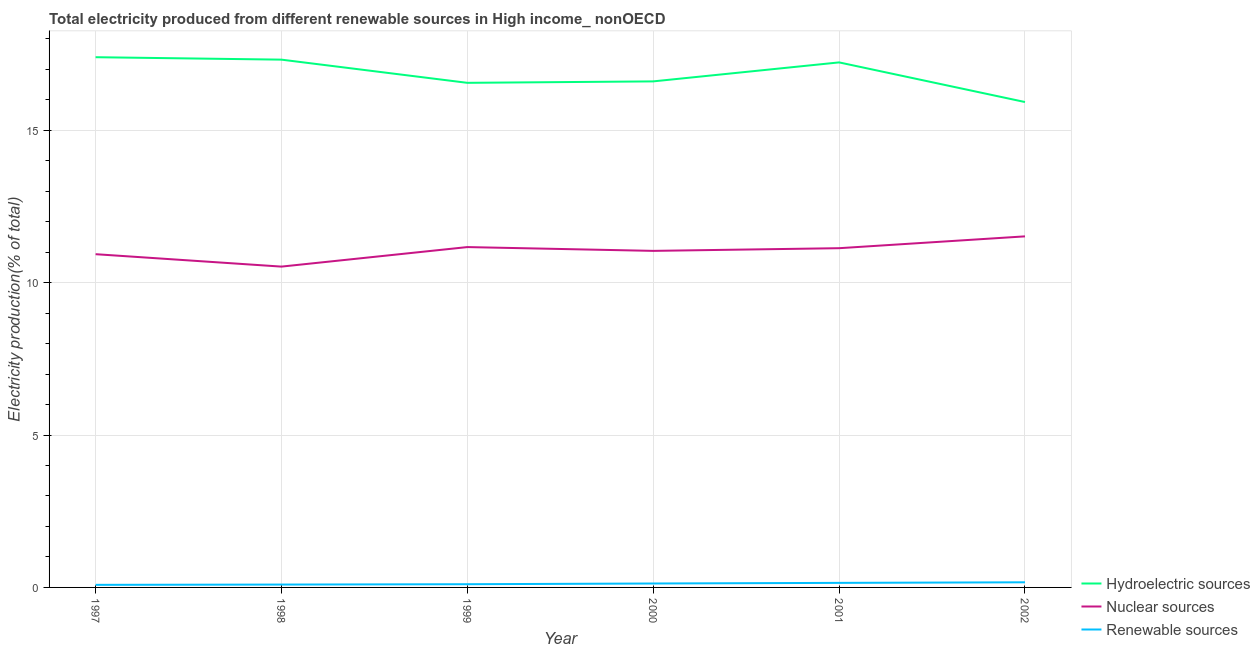How many different coloured lines are there?
Give a very brief answer. 3. Does the line corresponding to percentage of electricity produced by nuclear sources intersect with the line corresponding to percentage of electricity produced by renewable sources?
Ensure brevity in your answer.  No. Is the number of lines equal to the number of legend labels?
Make the answer very short. Yes. What is the percentage of electricity produced by nuclear sources in 1997?
Give a very brief answer. 10.93. Across all years, what is the maximum percentage of electricity produced by nuclear sources?
Offer a terse response. 11.52. Across all years, what is the minimum percentage of electricity produced by hydroelectric sources?
Ensure brevity in your answer.  15.92. In which year was the percentage of electricity produced by nuclear sources minimum?
Provide a short and direct response. 1998. What is the total percentage of electricity produced by hydroelectric sources in the graph?
Ensure brevity in your answer.  101.01. What is the difference between the percentage of electricity produced by renewable sources in 1997 and that in 1999?
Your answer should be very brief. -0.02. What is the difference between the percentage of electricity produced by renewable sources in 1997 and the percentage of electricity produced by nuclear sources in 2002?
Your answer should be compact. -11.43. What is the average percentage of electricity produced by hydroelectric sources per year?
Offer a very short reply. 16.83. In the year 2000, what is the difference between the percentage of electricity produced by nuclear sources and percentage of electricity produced by hydroelectric sources?
Your answer should be compact. -5.56. In how many years, is the percentage of electricity produced by nuclear sources greater than 12 %?
Keep it short and to the point. 0. What is the ratio of the percentage of electricity produced by nuclear sources in 1997 to that in 1999?
Provide a short and direct response. 0.98. Is the percentage of electricity produced by nuclear sources in 2000 less than that in 2001?
Provide a short and direct response. Yes. Is the difference between the percentage of electricity produced by renewable sources in 1997 and 2000 greater than the difference between the percentage of electricity produced by hydroelectric sources in 1997 and 2000?
Provide a succinct answer. No. What is the difference between the highest and the second highest percentage of electricity produced by renewable sources?
Ensure brevity in your answer.  0.02. What is the difference between the highest and the lowest percentage of electricity produced by renewable sources?
Make the answer very short. 0.08. In how many years, is the percentage of electricity produced by renewable sources greater than the average percentage of electricity produced by renewable sources taken over all years?
Your answer should be compact. 3. Is the percentage of electricity produced by renewable sources strictly less than the percentage of electricity produced by hydroelectric sources over the years?
Offer a terse response. Yes. How many lines are there?
Ensure brevity in your answer.  3. How many years are there in the graph?
Offer a terse response. 6. Are the values on the major ticks of Y-axis written in scientific E-notation?
Keep it short and to the point. No. Does the graph contain any zero values?
Your answer should be compact. No. How are the legend labels stacked?
Offer a terse response. Vertical. What is the title of the graph?
Offer a terse response. Total electricity produced from different renewable sources in High income_ nonOECD. Does "Services" appear as one of the legend labels in the graph?
Provide a succinct answer. No. What is the label or title of the Y-axis?
Ensure brevity in your answer.  Electricity production(% of total). What is the Electricity production(% of total) of Hydroelectric sources in 1997?
Keep it short and to the point. 17.39. What is the Electricity production(% of total) in Nuclear sources in 1997?
Provide a short and direct response. 10.93. What is the Electricity production(% of total) of Renewable sources in 1997?
Offer a terse response. 0.08. What is the Electricity production(% of total) of Hydroelectric sources in 1998?
Provide a succinct answer. 17.31. What is the Electricity production(% of total) of Nuclear sources in 1998?
Make the answer very short. 10.52. What is the Electricity production(% of total) of Renewable sources in 1998?
Offer a very short reply. 0.09. What is the Electricity production(% of total) of Hydroelectric sources in 1999?
Make the answer very short. 16.55. What is the Electricity production(% of total) in Nuclear sources in 1999?
Give a very brief answer. 11.17. What is the Electricity production(% of total) in Renewable sources in 1999?
Give a very brief answer. 0.11. What is the Electricity production(% of total) in Hydroelectric sources in 2000?
Provide a succinct answer. 16.6. What is the Electricity production(% of total) in Nuclear sources in 2000?
Ensure brevity in your answer.  11.04. What is the Electricity production(% of total) of Renewable sources in 2000?
Ensure brevity in your answer.  0.13. What is the Electricity production(% of total) of Hydroelectric sources in 2001?
Keep it short and to the point. 17.22. What is the Electricity production(% of total) of Nuclear sources in 2001?
Keep it short and to the point. 11.13. What is the Electricity production(% of total) in Renewable sources in 2001?
Provide a short and direct response. 0.15. What is the Electricity production(% of total) of Hydroelectric sources in 2002?
Give a very brief answer. 15.92. What is the Electricity production(% of total) of Nuclear sources in 2002?
Give a very brief answer. 11.52. What is the Electricity production(% of total) of Renewable sources in 2002?
Make the answer very short. 0.17. Across all years, what is the maximum Electricity production(% of total) in Hydroelectric sources?
Ensure brevity in your answer.  17.39. Across all years, what is the maximum Electricity production(% of total) in Nuclear sources?
Keep it short and to the point. 11.52. Across all years, what is the maximum Electricity production(% of total) of Renewable sources?
Your answer should be compact. 0.17. Across all years, what is the minimum Electricity production(% of total) in Hydroelectric sources?
Ensure brevity in your answer.  15.92. Across all years, what is the minimum Electricity production(% of total) of Nuclear sources?
Offer a terse response. 10.52. Across all years, what is the minimum Electricity production(% of total) of Renewable sources?
Make the answer very short. 0.08. What is the total Electricity production(% of total) in Hydroelectric sources in the graph?
Make the answer very short. 101.01. What is the total Electricity production(% of total) in Nuclear sources in the graph?
Your response must be concise. 66.31. What is the total Electricity production(% of total) in Renewable sources in the graph?
Your answer should be very brief. 0.73. What is the difference between the Electricity production(% of total) of Hydroelectric sources in 1997 and that in 1998?
Your response must be concise. 0.08. What is the difference between the Electricity production(% of total) in Nuclear sources in 1997 and that in 1998?
Keep it short and to the point. 0.41. What is the difference between the Electricity production(% of total) in Renewable sources in 1997 and that in 1998?
Keep it short and to the point. -0.01. What is the difference between the Electricity production(% of total) of Hydroelectric sources in 1997 and that in 1999?
Offer a terse response. 0.84. What is the difference between the Electricity production(% of total) in Nuclear sources in 1997 and that in 1999?
Your answer should be compact. -0.23. What is the difference between the Electricity production(% of total) of Renewable sources in 1997 and that in 1999?
Give a very brief answer. -0.02. What is the difference between the Electricity production(% of total) in Hydroelectric sources in 1997 and that in 2000?
Your answer should be very brief. 0.79. What is the difference between the Electricity production(% of total) of Nuclear sources in 1997 and that in 2000?
Provide a succinct answer. -0.11. What is the difference between the Electricity production(% of total) of Renewable sources in 1997 and that in 2000?
Give a very brief answer. -0.04. What is the difference between the Electricity production(% of total) of Hydroelectric sources in 1997 and that in 2001?
Ensure brevity in your answer.  0.17. What is the difference between the Electricity production(% of total) in Nuclear sources in 1997 and that in 2001?
Ensure brevity in your answer.  -0.2. What is the difference between the Electricity production(% of total) of Renewable sources in 1997 and that in 2001?
Make the answer very short. -0.06. What is the difference between the Electricity production(% of total) in Hydroelectric sources in 1997 and that in 2002?
Your answer should be very brief. 1.47. What is the difference between the Electricity production(% of total) in Nuclear sources in 1997 and that in 2002?
Offer a terse response. -0.58. What is the difference between the Electricity production(% of total) in Renewable sources in 1997 and that in 2002?
Your answer should be compact. -0.08. What is the difference between the Electricity production(% of total) of Hydroelectric sources in 1998 and that in 1999?
Your response must be concise. 0.76. What is the difference between the Electricity production(% of total) in Nuclear sources in 1998 and that in 1999?
Offer a very short reply. -0.64. What is the difference between the Electricity production(% of total) in Renewable sources in 1998 and that in 1999?
Offer a terse response. -0.01. What is the difference between the Electricity production(% of total) of Hydroelectric sources in 1998 and that in 2000?
Your answer should be very brief. 0.71. What is the difference between the Electricity production(% of total) of Nuclear sources in 1998 and that in 2000?
Make the answer very short. -0.52. What is the difference between the Electricity production(% of total) in Renewable sources in 1998 and that in 2000?
Offer a terse response. -0.03. What is the difference between the Electricity production(% of total) of Hydroelectric sources in 1998 and that in 2001?
Provide a short and direct response. 0.09. What is the difference between the Electricity production(% of total) of Nuclear sources in 1998 and that in 2001?
Offer a very short reply. -0.6. What is the difference between the Electricity production(% of total) in Renewable sources in 1998 and that in 2001?
Provide a short and direct response. -0.06. What is the difference between the Electricity production(% of total) of Hydroelectric sources in 1998 and that in 2002?
Keep it short and to the point. 1.39. What is the difference between the Electricity production(% of total) of Nuclear sources in 1998 and that in 2002?
Offer a very short reply. -0.99. What is the difference between the Electricity production(% of total) of Renewable sources in 1998 and that in 2002?
Give a very brief answer. -0.07. What is the difference between the Electricity production(% of total) in Hydroelectric sources in 1999 and that in 2000?
Keep it short and to the point. -0.05. What is the difference between the Electricity production(% of total) in Nuclear sources in 1999 and that in 2000?
Keep it short and to the point. 0.12. What is the difference between the Electricity production(% of total) in Renewable sources in 1999 and that in 2000?
Your response must be concise. -0.02. What is the difference between the Electricity production(% of total) in Hydroelectric sources in 1999 and that in 2001?
Your answer should be very brief. -0.67. What is the difference between the Electricity production(% of total) of Nuclear sources in 1999 and that in 2001?
Provide a succinct answer. 0.04. What is the difference between the Electricity production(% of total) of Renewable sources in 1999 and that in 2001?
Your answer should be very brief. -0.04. What is the difference between the Electricity production(% of total) of Hydroelectric sources in 1999 and that in 2002?
Offer a very short reply. 0.63. What is the difference between the Electricity production(% of total) in Nuclear sources in 1999 and that in 2002?
Keep it short and to the point. -0.35. What is the difference between the Electricity production(% of total) of Renewable sources in 1999 and that in 2002?
Offer a very short reply. -0.06. What is the difference between the Electricity production(% of total) in Hydroelectric sources in 2000 and that in 2001?
Your response must be concise. -0.62. What is the difference between the Electricity production(% of total) of Nuclear sources in 2000 and that in 2001?
Your response must be concise. -0.09. What is the difference between the Electricity production(% of total) of Renewable sources in 2000 and that in 2001?
Offer a very short reply. -0.02. What is the difference between the Electricity production(% of total) of Hydroelectric sources in 2000 and that in 2002?
Provide a short and direct response. 0.68. What is the difference between the Electricity production(% of total) of Nuclear sources in 2000 and that in 2002?
Provide a succinct answer. -0.48. What is the difference between the Electricity production(% of total) of Renewable sources in 2000 and that in 2002?
Keep it short and to the point. -0.04. What is the difference between the Electricity production(% of total) in Nuclear sources in 2001 and that in 2002?
Provide a short and direct response. -0.39. What is the difference between the Electricity production(% of total) in Renewable sources in 2001 and that in 2002?
Your answer should be very brief. -0.02. What is the difference between the Electricity production(% of total) in Hydroelectric sources in 1997 and the Electricity production(% of total) in Nuclear sources in 1998?
Provide a short and direct response. 6.87. What is the difference between the Electricity production(% of total) in Hydroelectric sources in 1997 and the Electricity production(% of total) in Renewable sources in 1998?
Your answer should be very brief. 17.3. What is the difference between the Electricity production(% of total) of Nuclear sources in 1997 and the Electricity production(% of total) of Renewable sources in 1998?
Provide a short and direct response. 10.84. What is the difference between the Electricity production(% of total) of Hydroelectric sources in 1997 and the Electricity production(% of total) of Nuclear sources in 1999?
Ensure brevity in your answer.  6.23. What is the difference between the Electricity production(% of total) in Hydroelectric sources in 1997 and the Electricity production(% of total) in Renewable sources in 1999?
Provide a succinct answer. 17.29. What is the difference between the Electricity production(% of total) in Nuclear sources in 1997 and the Electricity production(% of total) in Renewable sources in 1999?
Keep it short and to the point. 10.83. What is the difference between the Electricity production(% of total) of Hydroelectric sources in 1997 and the Electricity production(% of total) of Nuclear sources in 2000?
Your answer should be very brief. 6.35. What is the difference between the Electricity production(% of total) of Hydroelectric sources in 1997 and the Electricity production(% of total) of Renewable sources in 2000?
Offer a terse response. 17.27. What is the difference between the Electricity production(% of total) in Nuclear sources in 1997 and the Electricity production(% of total) in Renewable sources in 2000?
Provide a short and direct response. 10.8. What is the difference between the Electricity production(% of total) of Hydroelectric sources in 1997 and the Electricity production(% of total) of Nuclear sources in 2001?
Your answer should be compact. 6.27. What is the difference between the Electricity production(% of total) of Hydroelectric sources in 1997 and the Electricity production(% of total) of Renewable sources in 2001?
Offer a terse response. 17.24. What is the difference between the Electricity production(% of total) in Nuclear sources in 1997 and the Electricity production(% of total) in Renewable sources in 2001?
Make the answer very short. 10.78. What is the difference between the Electricity production(% of total) of Hydroelectric sources in 1997 and the Electricity production(% of total) of Nuclear sources in 2002?
Your answer should be very brief. 5.88. What is the difference between the Electricity production(% of total) of Hydroelectric sources in 1997 and the Electricity production(% of total) of Renewable sources in 2002?
Keep it short and to the point. 17.23. What is the difference between the Electricity production(% of total) in Nuclear sources in 1997 and the Electricity production(% of total) in Renewable sources in 2002?
Provide a succinct answer. 10.76. What is the difference between the Electricity production(% of total) in Hydroelectric sources in 1998 and the Electricity production(% of total) in Nuclear sources in 1999?
Offer a very short reply. 6.15. What is the difference between the Electricity production(% of total) of Hydroelectric sources in 1998 and the Electricity production(% of total) of Renewable sources in 1999?
Make the answer very short. 17.21. What is the difference between the Electricity production(% of total) in Nuclear sources in 1998 and the Electricity production(% of total) in Renewable sources in 1999?
Keep it short and to the point. 10.42. What is the difference between the Electricity production(% of total) of Hydroelectric sources in 1998 and the Electricity production(% of total) of Nuclear sources in 2000?
Make the answer very short. 6.27. What is the difference between the Electricity production(% of total) of Hydroelectric sources in 1998 and the Electricity production(% of total) of Renewable sources in 2000?
Give a very brief answer. 17.19. What is the difference between the Electricity production(% of total) in Nuclear sources in 1998 and the Electricity production(% of total) in Renewable sources in 2000?
Provide a short and direct response. 10.4. What is the difference between the Electricity production(% of total) in Hydroelectric sources in 1998 and the Electricity production(% of total) in Nuclear sources in 2001?
Your answer should be very brief. 6.19. What is the difference between the Electricity production(% of total) in Hydroelectric sources in 1998 and the Electricity production(% of total) in Renewable sources in 2001?
Give a very brief answer. 17.16. What is the difference between the Electricity production(% of total) of Nuclear sources in 1998 and the Electricity production(% of total) of Renewable sources in 2001?
Give a very brief answer. 10.38. What is the difference between the Electricity production(% of total) of Hydroelectric sources in 1998 and the Electricity production(% of total) of Nuclear sources in 2002?
Offer a very short reply. 5.8. What is the difference between the Electricity production(% of total) in Hydroelectric sources in 1998 and the Electricity production(% of total) in Renewable sources in 2002?
Make the answer very short. 17.15. What is the difference between the Electricity production(% of total) in Nuclear sources in 1998 and the Electricity production(% of total) in Renewable sources in 2002?
Keep it short and to the point. 10.36. What is the difference between the Electricity production(% of total) of Hydroelectric sources in 1999 and the Electricity production(% of total) of Nuclear sources in 2000?
Give a very brief answer. 5.51. What is the difference between the Electricity production(% of total) of Hydroelectric sources in 1999 and the Electricity production(% of total) of Renewable sources in 2000?
Give a very brief answer. 16.42. What is the difference between the Electricity production(% of total) of Nuclear sources in 1999 and the Electricity production(% of total) of Renewable sources in 2000?
Your answer should be very brief. 11.04. What is the difference between the Electricity production(% of total) in Hydroelectric sources in 1999 and the Electricity production(% of total) in Nuclear sources in 2001?
Give a very brief answer. 5.42. What is the difference between the Electricity production(% of total) in Hydroelectric sources in 1999 and the Electricity production(% of total) in Renewable sources in 2001?
Your answer should be very brief. 16.4. What is the difference between the Electricity production(% of total) of Nuclear sources in 1999 and the Electricity production(% of total) of Renewable sources in 2001?
Provide a short and direct response. 11.02. What is the difference between the Electricity production(% of total) of Hydroelectric sources in 1999 and the Electricity production(% of total) of Nuclear sources in 2002?
Keep it short and to the point. 5.04. What is the difference between the Electricity production(% of total) of Hydroelectric sources in 1999 and the Electricity production(% of total) of Renewable sources in 2002?
Provide a short and direct response. 16.38. What is the difference between the Electricity production(% of total) in Nuclear sources in 1999 and the Electricity production(% of total) in Renewable sources in 2002?
Give a very brief answer. 11. What is the difference between the Electricity production(% of total) of Hydroelectric sources in 2000 and the Electricity production(% of total) of Nuclear sources in 2001?
Provide a short and direct response. 5.47. What is the difference between the Electricity production(% of total) of Hydroelectric sources in 2000 and the Electricity production(% of total) of Renewable sources in 2001?
Give a very brief answer. 16.45. What is the difference between the Electricity production(% of total) in Nuclear sources in 2000 and the Electricity production(% of total) in Renewable sources in 2001?
Keep it short and to the point. 10.89. What is the difference between the Electricity production(% of total) of Hydroelectric sources in 2000 and the Electricity production(% of total) of Nuclear sources in 2002?
Keep it short and to the point. 5.08. What is the difference between the Electricity production(% of total) in Hydroelectric sources in 2000 and the Electricity production(% of total) in Renewable sources in 2002?
Offer a terse response. 16.43. What is the difference between the Electricity production(% of total) in Nuclear sources in 2000 and the Electricity production(% of total) in Renewable sources in 2002?
Make the answer very short. 10.87. What is the difference between the Electricity production(% of total) of Hydroelectric sources in 2001 and the Electricity production(% of total) of Nuclear sources in 2002?
Your answer should be very brief. 5.71. What is the difference between the Electricity production(% of total) of Hydroelectric sources in 2001 and the Electricity production(% of total) of Renewable sources in 2002?
Keep it short and to the point. 17.05. What is the difference between the Electricity production(% of total) in Nuclear sources in 2001 and the Electricity production(% of total) in Renewable sources in 2002?
Offer a terse response. 10.96. What is the average Electricity production(% of total) of Hydroelectric sources per year?
Your response must be concise. 16.83. What is the average Electricity production(% of total) of Nuclear sources per year?
Keep it short and to the point. 11.05. What is the average Electricity production(% of total) of Renewable sources per year?
Provide a short and direct response. 0.12. In the year 1997, what is the difference between the Electricity production(% of total) in Hydroelectric sources and Electricity production(% of total) in Nuclear sources?
Make the answer very short. 6.46. In the year 1997, what is the difference between the Electricity production(% of total) of Hydroelectric sources and Electricity production(% of total) of Renewable sources?
Keep it short and to the point. 17.31. In the year 1997, what is the difference between the Electricity production(% of total) in Nuclear sources and Electricity production(% of total) in Renewable sources?
Make the answer very short. 10.85. In the year 1998, what is the difference between the Electricity production(% of total) in Hydroelectric sources and Electricity production(% of total) in Nuclear sources?
Keep it short and to the point. 6.79. In the year 1998, what is the difference between the Electricity production(% of total) of Hydroelectric sources and Electricity production(% of total) of Renewable sources?
Your answer should be very brief. 17.22. In the year 1998, what is the difference between the Electricity production(% of total) of Nuclear sources and Electricity production(% of total) of Renewable sources?
Your response must be concise. 10.43. In the year 1999, what is the difference between the Electricity production(% of total) in Hydroelectric sources and Electricity production(% of total) in Nuclear sources?
Your response must be concise. 5.39. In the year 1999, what is the difference between the Electricity production(% of total) of Hydroelectric sources and Electricity production(% of total) of Renewable sources?
Your answer should be compact. 16.45. In the year 1999, what is the difference between the Electricity production(% of total) of Nuclear sources and Electricity production(% of total) of Renewable sources?
Provide a succinct answer. 11.06. In the year 2000, what is the difference between the Electricity production(% of total) of Hydroelectric sources and Electricity production(% of total) of Nuclear sources?
Offer a terse response. 5.56. In the year 2000, what is the difference between the Electricity production(% of total) in Hydroelectric sources and Electricity production(% of total) in Renewable sources?
Your response must be concise. 16.47. In the year 2000, what is the difference between the Electricity production(% of total) in Nuclear sources and Electricity production(% of total) in Renewable sources?
Keep it short and to the point. 10.91. In the year 2001, what is the difference between the Electricity production(% of total) in Hydroelectric sources and Electricity production(% of total) in Nuclear sources?
Provide a succinct answer. 6.09. In the year 2001, what is the difference between the Electricity production(% of total) of Hydroelectric sources and Electricity production(% of total) of Renewable sources?
Keep it short and to the point. 17.07. In the year 2001, what is the difference between the Electricity production(% of total) in Nuclear sources and Electricity production(% of total) in Renewable sources?
Your response must be concise. 10.98. In the year 2002, what is the difference between the Electricity production(% of total) in Hydroelectric sources and Electricity production(% of total) in Nuclear sources?
Provide a short and direct response. 4.41. In the year 2002, what is the difference between the Electricity production(% of total) of Hydroelectric sources and Electricity production(% of total) of Renewable sources?
Your response must be concise. 15.75. In the year 2002, what is the difference between the Electricity production(% of total) in Nuclear sources and Electricity production(% of total) in Renewable sources?
Keep it short and to the point. 11.35. What is the ratio of the Electricity production(% of total) of Nuclear sources in 1997 to that in 1998?
Your answer should be compact. 1.04. What is the ratio of the Electricity production(% of total) in Hydroelectric sources in 1997 to that in 1999?
Offer a terse response. 1.05. What is the ratio of the Electricity production(% of total) in Nuclear sources in 1997 to that in 1999?
Offer a terse response. 0.98. What is the ratio of the Electricity production(% of total) of Renewable sources in 1997 to that in 1999?
Keep it short and to the point. 0.8. What is the ratio of the Electricity production(% of total) of Hydroelectric sources in 1997 to that in 2000?
Offer a terse response. 1.05. What is the ratio of the Electricity production(% of total) of Nuclear sources in 1997 to that in 2000?
Provide a short and direct response. 0.99. What is the ratio of the Electricity production(% of total) in Renewable sources in 1997 to that in 2000?
Your response must be concise. 0.66. What is the ratio of the Electricity production(% of total) in Hydroelectric sources in 1997 to that in 2001?
Your response must be concise. 1.01. What is the ratio of the Electricity production(% of total) in Nuclear sources in 1997 to that in 2001?
Make the answer very short. 0.98. What is the ratio of the Electricity production(% of total) of Renewable sources in 1997 to that in 2001?
Ensure brevity in your answer.  0.57. What is the ratio of the Electricity production(% of total) in Hydroelectric sources in 1997 to that in 2002?
Provide a succinct answer. 1.09. What is the ratio of the Electricity production(% of total) of Nuclear sources in 1997 to that in 2002?
Make the answer very short. 0.95. What is the ratio of the Electricity production(% of total) of Renewable sources in 1997 to that in 2002?
Make the answer very short. 0.5. What is the ratio of the Electricity production(% of total) in Hydroelectric sources in 1998 to that in 1999?
Keep it short and to the point. 1.05. What is the ratio of the Electricity production(% of total) in Nuclear sources in 1998 to that in 1999?
Your answer should be compact. 0.94. What is the ratio of the Electricity production(% of total) in Renewable sources in 1998 to that in 1999?
Offer a very short reply. 0.89. What is the ratio of the Electricity production(% of total) of Hydroelectric sources in 1998 to that in 2000?
Offer a very short reply. 1.04. What is the ratio of the Electricity production(% of total) of Nuclear sources in 1998 to that in 2000?
Your response must be concise. 0.95. What is the ratio of the Electricity production(% of total) in Renewable sources in 1998 to that in 2000?
Offer a terse response. 0.73. What is the ratio of the Electricity production(% of total) in Hydroelectric sources in 1998 to that in 2001?
Ensure brevity in your answer.  1.01. What is the ratio of the Electricity production(% of total) in Nuclear sources in 1998 to that in 2001?
Provide a succinct answer. 0.95. What is the ratio of the Electricity production(% of total) of Renewable sources in 1998 to that in 2001?
Provide a short and direct response. 0.63. What is the ratio of the Electricity production(% of total) of Hydroelectric sources in 1998 to that in 2002?
Offer a very short reply. 1.09. What is the ratio of the Electricity production(% of total) in Nuclear sources in 1998 to that in 2002?
Provide a short and direct response. 0.91. What is the ratio of the Electricity production(% of total) in Renewable sources in 1998 to that in 2002?
Your answer should be very brief. 0.56. What is the ratio of the Electricity production(% of total) of Hydroelectric sources in 1999 to that in 2000?
Offer a terse response. 1. What is the ratio of the Electricity production(% of total) in Nuclear sources in 1999 to that in 2000?
Provide a short and direct response. 1.01. What is the ratio of the Electricity production(% of total) of Renewable sources in 1999 to that in 2000?
Offer a terse response. 0.82. What is the ratio of the Electricity production(% of total) of Hydroelectric sources in 1999 to that in 2001?
Your answer should be compact. 0.96. What is the ratio of the Electricity production(% of total) of Renewable sources in 1999 to that in 2001?
Provide a short and direct response. 0.71. What is the ratio of the Electricity production(% of total) of Hydroelectric sources in 1999 to that in 2002?
Make the answer very short. 1.04. What is the ratio of the Electricity production(% of total) in Nuclear sources in 1999 to that in 2002?
Keep it short and to the point. 0.97. What is the ratio of the Electricity production(% of total) in Renewable sources in 1999 to that in 2002?
Give a very brief answer. 0.63. What is the ratio of the Electricity production(% of total) of Hydroelectric sources in 2000 to that in 2001?
Your response must be concise. 0.96. What is the ratio of the Electricity production(% of total) of Renewable sources in 2000 to that in 2001?
Offer a very short reply. 0.86. What is the ratio of the Electricity production(% of total) of Hydroelectric sources in 2000 to that in 2002?
Make the answer very short. 1.04. What is the ratio of the Electricity production(% of total) of Nuclear sources in 2000 to that in 2002?
Make the answer very short. 0.96. What is the ratio of the Electricity production(% of total) in Renewable sources in 2000 to that in 2002?
Your response must be concise. 0.76. What is the ratio of the Electricity production(% of total) in Hydroelectric sources in 2001 to that in 2002?
Make the answer very short. 1.08. What is the ratio of the Electricity production(% of total) in Nuclear sources in 2001 to that in 2002?
Make the answer very short. 0.97. What is the ratio of the Electricity production(% of total) in Renewable sources in 2001 to that in 2002?
Provide a short and direct response. 0.89. What is the difference between the highest and the second highest Electricity production(% of total) in Hydroelectric sources?
Offer a terse response. 0.08. What is the difference between the highest and the second highest Electricity production(% of total) in Nuclear sources?
Provide a short and direct response. 0.35. What is the difference between the highest and the second highest Electricity production(% of total) in Renewable sources?
Provide a short and direct response. 0.02. What is the difference between the highest and the lowest Electricity production(% of total) of Hydroelectric sources?
Give a very brief answer. 1.47. What is the difference between the highest and the lowest Electricity production(% of total) in Renewable sources?
Give a very brief answer. 0.08. 